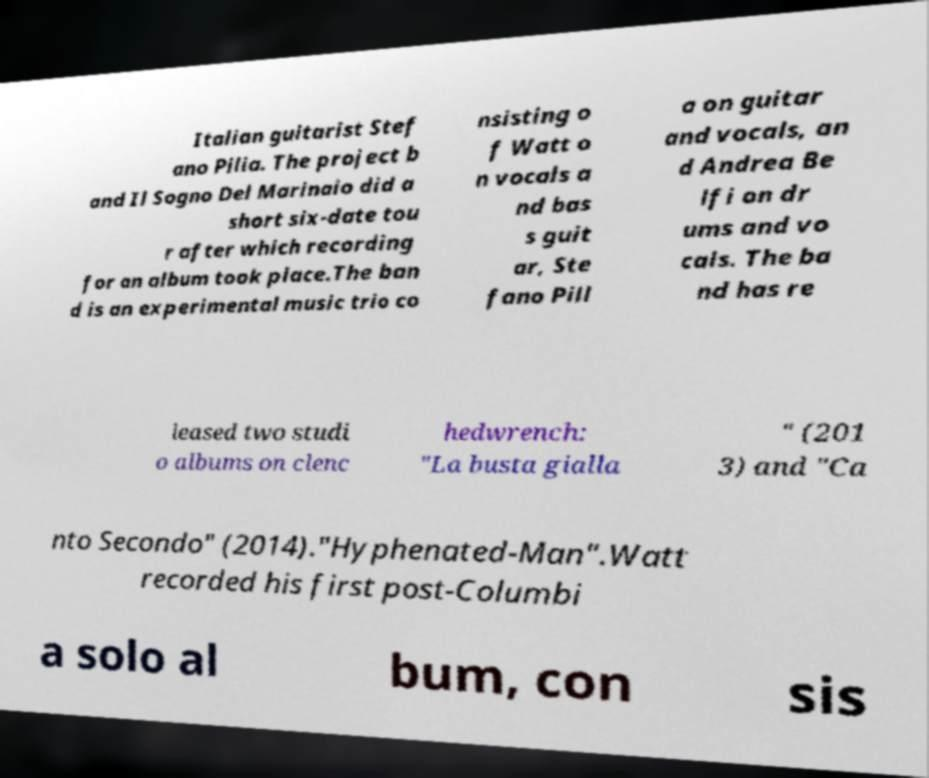Can you read and provide the text displayed in the image?This photo seems to have some interesting text. Can you extract and type it out for me? Italian guitarist Stef ano Pilia. The project b and Il Sogno Del Marinaio did a short six-date tou r after which recording for an album took place.The ban d is an experimental music trio co nsisting o f Watt o n vocals a nd bas s guit ar, Ste fano Pill a on guitar and vocals, an d Andrea Be lfi on dr ums and vo cals. The ba nd has re leased two studi o albums on clenc hedwrench: "La busta gialla " (201 3) and "Ca nto Secondo" (2014)."Hyphenated-Man".Watt recorded his first post-Columbi a solo al bum, con sis 